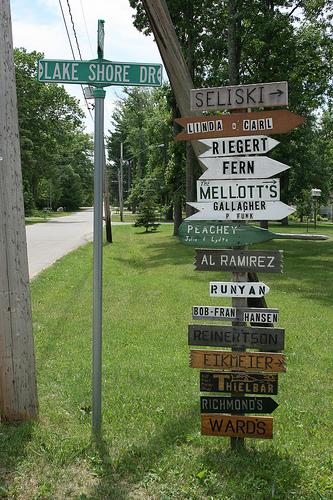Please mention the distinct colors of the arrow signs in the image. Brown, white, green, and black arrow signs Point out something that is related to the environment or nature in this image. Several large trees with green leaves Give a count of the trees in the image, and mention their color. There are several tall green trees. How many signs are there in the image with names written on them? Fifteen signs with last names List different shapes of name signs found in the stack. Rectangular, arrow-shaped, oar-shaped, and paddle-shaped signs In a single sentence, describe the scene depicted in the image. The image shows a collection of various-shaped, colorful signs with names and arrows placed on a pole, with trees and a bird house in the background. Describe the imagery scene in simple words for a child to understand. The picture shows many signs with people's names on a big pole near some trees and a little bird house. Take a look at the group of people gathered under the streetlight, discussing the numerous signs on the pole. Can you make out the conversation? There is no mention of people in the provided data, specifically near the streetlight or signs. By asking about the conversation, the instruction only serves to further confuse the reader. What type of tree is shown near the road? Small pine tree Look for a massive red fire hydrant next to the tall trees. Is it there? There is no mention of a fire hydrant, let alone a red one, in the given data. Additionally, the request to look for it in the context of an interrogative sentence further misleads the reader. Describe the shape of the green wooden sign for Gallagher family.  The sign is shaped like a boat oar. Pay close attention to a bright yellow car parked alongside the road in this neighborhood. Is its license plate visible? There is no mention of a car, specifically a bright yellow one, in the data. The reference to a possible license plate only serves to further mislead the reader. What are the signs with last names painted and made of? The signs are painted and made of wood. What is the rectangular wooden sign at the top displaying? A sign for the Seliski family Choose the correct statement out of the following options: a) The white bird house is on a pole near the Fern sign. b) The white bird house is on a pole near the Eikmeier sign. a) The white bird house is on a pole near the Fern sign. What does the green street sign with white lettering say? Wards What do several large trees with green leaves and power lines in the background represent in the image? The trees represent the natural landscape, and the power lines represent infrastructure. Is there a mailbox in the image, if so, what does it look like? Yes, there is a mailbox beside the paved road. Gaze at the picturesque white picket fence surrounding a beautiful garden near the small pine tree. Can you spot any blooming flowers? There is no mention of a fence, white picket or otherwise, nor is there any reference to a garden. The data only discusses the presence of a small pine tree, making the search for blooming flowers irrelevant. What does the streetlight structure besides the road look like? The streetlight is a metal structure placed beside the road. Identify the presence of electrical wires in the image. The electrical wires are present in the sky. Identify the activity taking place near the small pine tree. There is no specific activity happening near the small pine tree. Which sign says "Runyan" and what color is it? The white arrow sign says Runyan in black letters. Observe the stunning rainbow forming above the powerlines and telephone poles. Is it a full arc, or only partial? There is no mention of a rainbow in the provided data, so asking about its formation and characteristics is a misleading instruction. What is the color of the arrow pointing to the Mellott family sign? White How many signs are on the pole? Fifteen Perform a quick count of the total landscape rocks on the ground and give the number of rocks. One Examine the street corner for a playful squirrel darting around a pile of autumn leaves. Does it seem like it's having fun? The data does not mention any animal or living creature, especially squirrels or autumn leaves. The instruction is any information about the squirrel and its actions is not supported by the provided data. Describe the interaction between the signs on a pole and the mailbox beside the paved road. There is no direct interaction between the signs and the mailbox, but both are placed beside the road for visibility. Which signs are brown and arrow-shaped? The sign for Linda and Carl has a brown arrow shape with white and black name letters. 